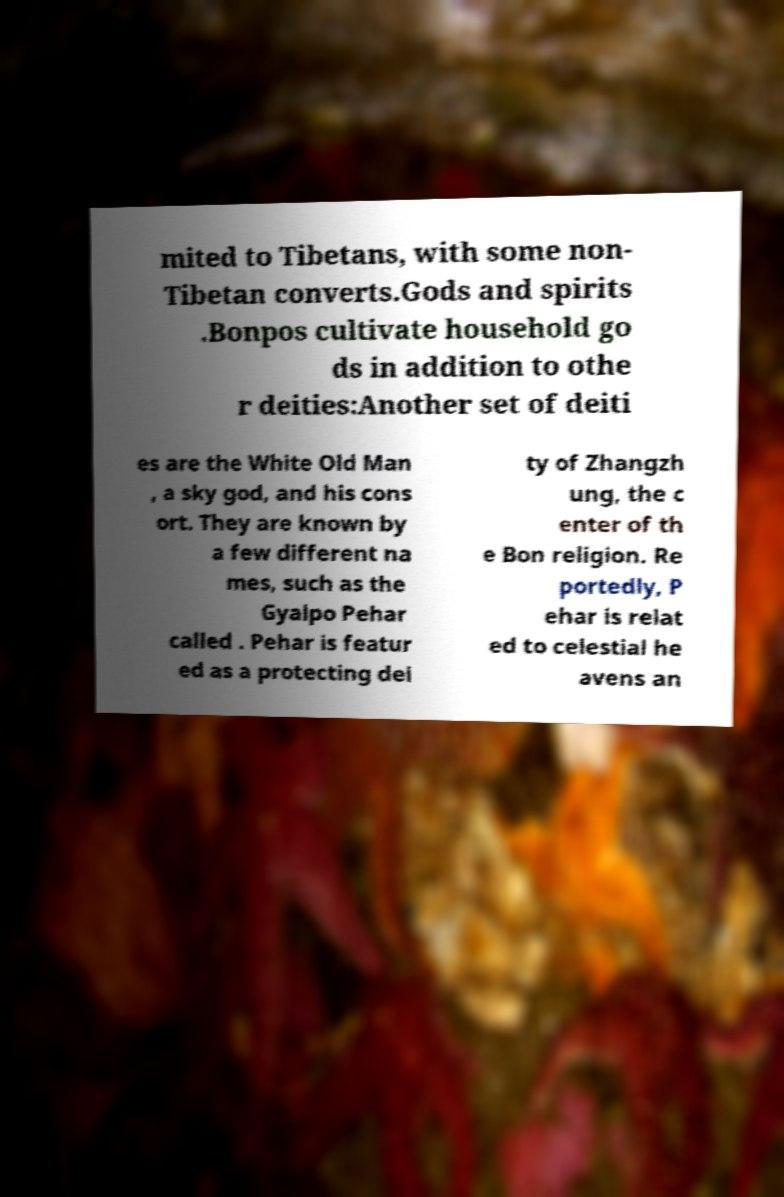I need the written content from this picture converted into text. Can you do that? mited to Tibetans, with some non- Tibetan converts.Gods and spirits .Bonpos cultivate household go ds in addition to othe r deities:Another set of deiti es are the White Old Man , a sky god, and his cons ort. They are known by a few different na mes, such as the Gyalpo Pehar called . Pehar is featur ed as a protecting dei ty of Zhangzh ung, the c enter of th e Bon religion. Re portedly, P ehar is relat ed to celestial he avens an 